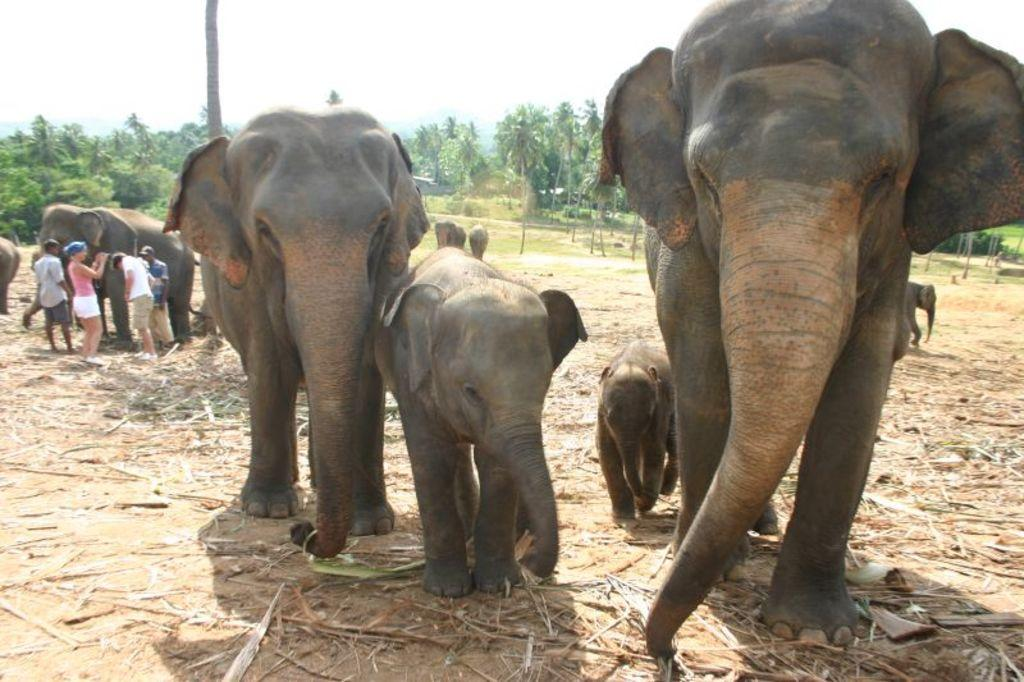What animals are present in the image? There are elephants in the image. What type of vegetation can be seen in the image? There is dried grass and grass visible in the image. What else can be seen in the image besides the elephants and vegetation? There are people standing in the image. What is visible in the background of the image? There are trees, grass, and the sky visible in the background of the image. How many holes can be seen in the image? There are no holes present in the image. What type of cats can be seen playing with the elephants in the image? There are no cats present in the image, and the elephants are not interacting with any animals. 